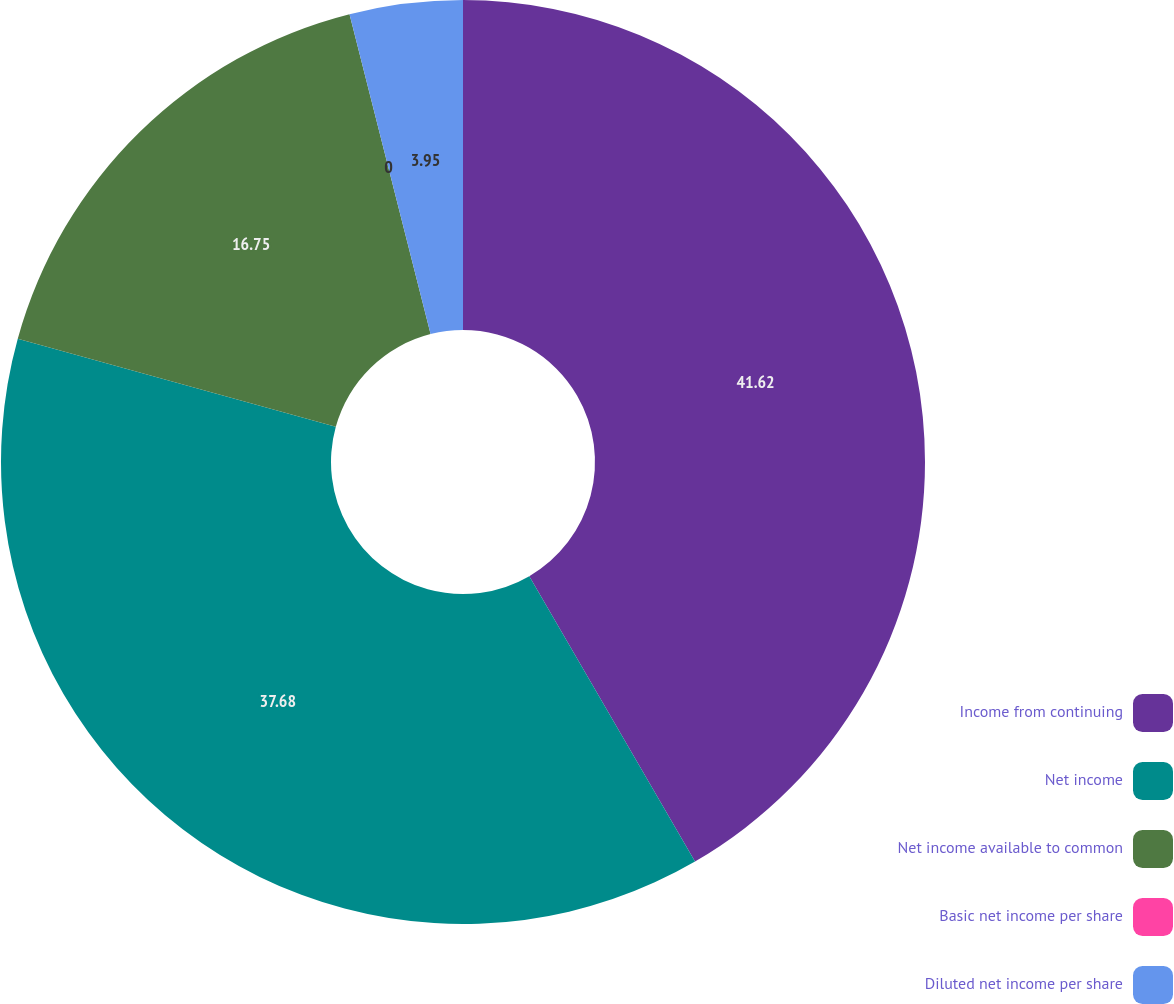Convert chart to OTSL. <chart><loc_0><loc_0><loc_500><loc_500><pie_chart><fcel>Income from continuing<fcel>Net income<fcel>Net income available to common<fcel>Basic net income per share<fcel>Diluted net income per share<nl><fcel>41.63%<fcel>37.68%<fcel>16.75%<fcel>0.0%<fcel>3.95%<nl></chart> 